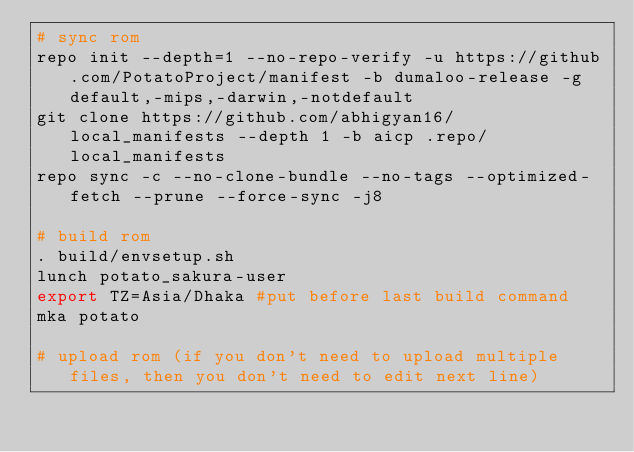Convert code to text. <code><loc_0><loc_0><loc_500><loc_500><_Bash_># sync rom
repo init --depth=1 --no-repo-verify -u https://github.com/PotatoProject/manifest -b dumaloo-release -g default,-mips,-darwin,-notdefault
git clone https://github.com/abhigyan16/local_manifests --depth 1 -b aicp .repo/local_manifests
repo sync -c --no-clone-bundle --no-tags --optimized-fetch --prune --force-sync -j8

# build rom
. build/envsetup.sh
lunch potato_sakura-user
export TZ=Asia/Dhaka #put before last build command
mka potato

# upload rom (if you don't need to upload multiple files, then you don't need to edit next line)</code> 